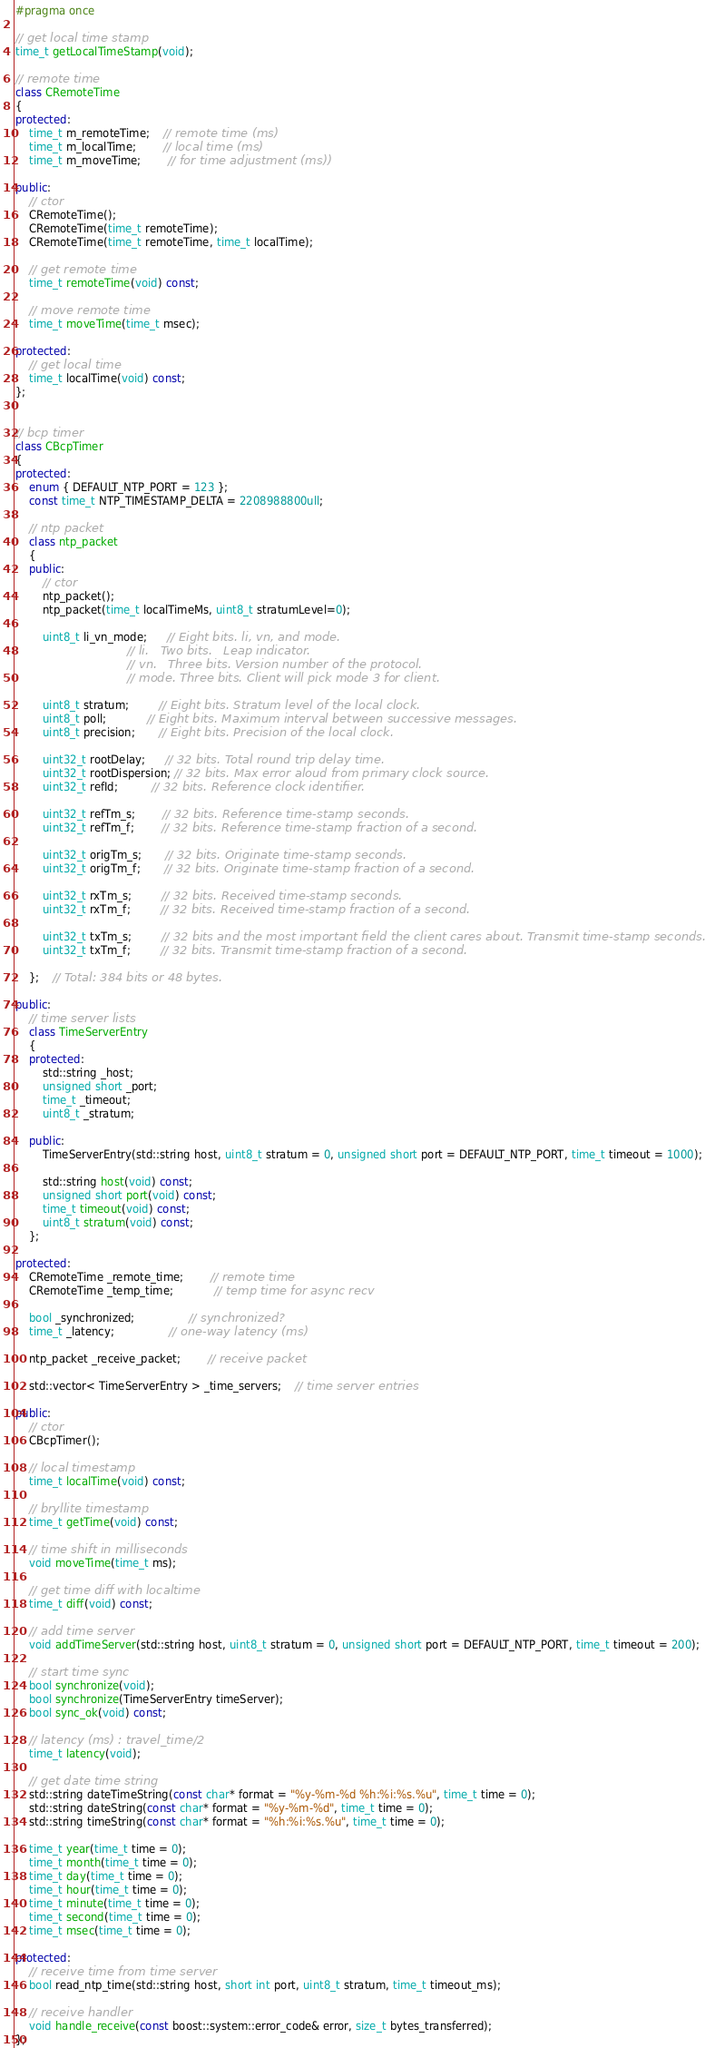<code> <loc_0><loc_0><loc_500><loc_500><_C++_>#pragma once

// get local time stamp
time_t getLocalTimeStamp(void);

// remote time
class CRemoteTime
{
protected:
	time_t m_remoteTime;	// remote time (ms)
	time_t m_localTime;		// local time (ms)
	time_t m_moveTime;		// for time adjustment (ms))

public:
	// ctor
	CRemoteTime();
	CRemoteTime(time_t remoteTime);
	CRemoteTime(time_t remoteTime, time_t localTime);

	// get remote time
	time_t remoteTime(void) const;

	// move remote time
	time_t moveTime(time_t msec);

protected:
	// get local time
	time_t localTime(void) const;
};


// bcp timer
class CBcpTimer
{
protected:
	enum { DEFAULT_NTP_PORT = 123 };
	const time_t NTP_TIMESTAMP_DELTA = 2208988800ull;

	// ntp packet
	class ntp_packet
	{
	public:
		// ctor
		ntp_packet();
		ntp_packet(time_t localTimeMs, uint8_t stratumLevel=0);

		uint8_t li_vn_mode;      // Eight bits. li, vn, and mode.
								 // li.   Two bits.   Leap indicator.
								 // vn.   Three bits. Version number of the protocol.
								 // mode. Three bits. Client will pick mode 3 for client.

		uint8_t stratum;         // Eight bits. Stratum level of the local clock.
		uint8_t poll;            // Eight bits. Maximum interval between successive messages.
		uint8_t precision;       // Eight bits. Precision of the local clock.

		uint32_t rootDelay;      // 32 bits. Total round trip delay time.
		uint32_t rootDispersion; // 32 bits. Max error aloud from primary clock source.
		uint32_t refId;          // 32 bits. Reference clock identifier.

		uint32_t refTm_s;        // 32 bits. Reference time-stamp seconds.
		uint32_t refTm_f;        // 32 bits. Reference time-stamp fraction of a second.

		uint32_t origTm_s;       // 32 bits. Originate time-stamp seconds.
		uint32_t origTm_f;       // 32 bits. Originate time-stamp fraction of a second.

		uint32_t rxTm_s;         // 32 bits. Received time-stamp seconds.
		uint32_t rxTm_f;         // 32 bits. Received time-stamp fraction of a second.

		uint32_t txTm_s;         // 32 bits and the most important field the client cares about. Transmit time-stamp seconds.
		uint32_t txTm_f;         // 32 bits. Transmit time-stamp fraction of a second.

	};	// Total: 384 bits or 48 bytes.

public:
	// time server lists
	class TimeServerEntry
	{
	protected:
		std::string _host;
		unsigned short _port;
		time_t _timeout;
		uint8_t _stratum;

	public:
		TimeServerEntry(std::string host, uint8_t stratum = 0, unsigned short port = DEFAULT_NTP_PORT, time_t timeout = 1000);

		std::string host(void) const;
		unsigned short port(void) const;
		time_t timeout(void) const;
		uint8_t stratum(void) const;
	};

protected:
	CRemoteTime _remote_time;		// remote time
	CRemoteTime _temp_time;			// temp time for async recv

	bool _synchronized;				// synchronized?
	time_t _latency;				// one-way latency (ms)

	ntp_packet _receive_packet;		// receive packet

	std::vector< TimeServerEntry > _time_servers;	// time server entries

public:
	// ctor
	CBcpTimer();

	// local timestamp
	time_t localTime(void) const;

	// bryllite timestamp
	time_t getTime(void) const;

	// time shift in milliseconds
	void moveTime(time_t ms);

	// get time diff with localtime
	time_t diff(void) const;

	// add time server
	void addTimeServer(std::string host, uint8_t stratum = 0, unsigned short port = DEFAULT_NTP_PORT, time_t timeout = 200);

	// start time sync
	bool synchronize(void);
	bool synchronize(TimeServerEntry timeServer);
	bool sync_ok(void) const;

	// latency (ms) : travel_time/2
	time_t latency(void);

	// get date time string
	std::string dateTimeString(const char* format = "%y-%m-%d %h:%i:%s.%u", time_t time = 0);
	std::string dateString(const char* format = "%y-%m-%d", time_t time = 0);
	std::string timeString(const char* format = "%h:%i:%s.%u", time_t time = 0);

	time_t year(time_t time = 0);
	time_t month(time_t time = 0);
	time_t day(time_t time = 0);
	time_t hour(time_t time = 0);
	time_t minute(time_t time = 0);
	time_t second(time_t time = 0);
	time_t msec(time_t time = 0);

protected:
	// receive time from time server
	bool read_ntp_time(std::string host, short int port, uint8_t stratum, time_t timeout_ms);

	// receive handler
	void handle_receive(const boost::system::error_code& error, size_t bytes_transferred);
};
</code> 